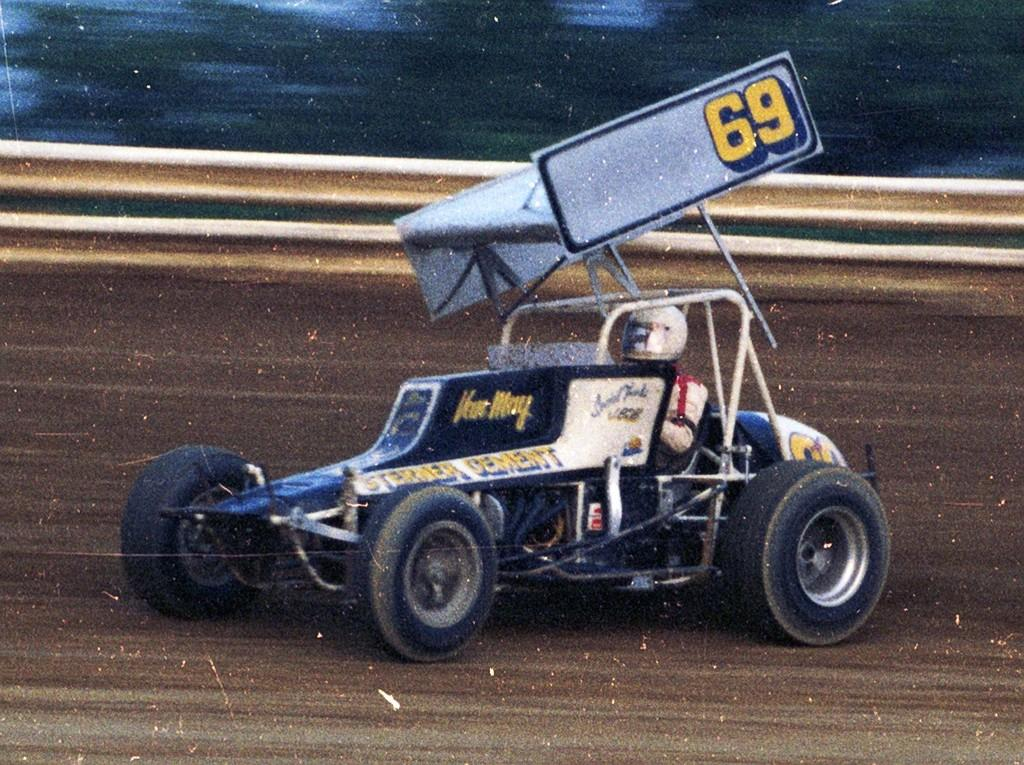<image>
Write a terse but informative summary of the picture. An offroad vehicle with number 69 on a track 